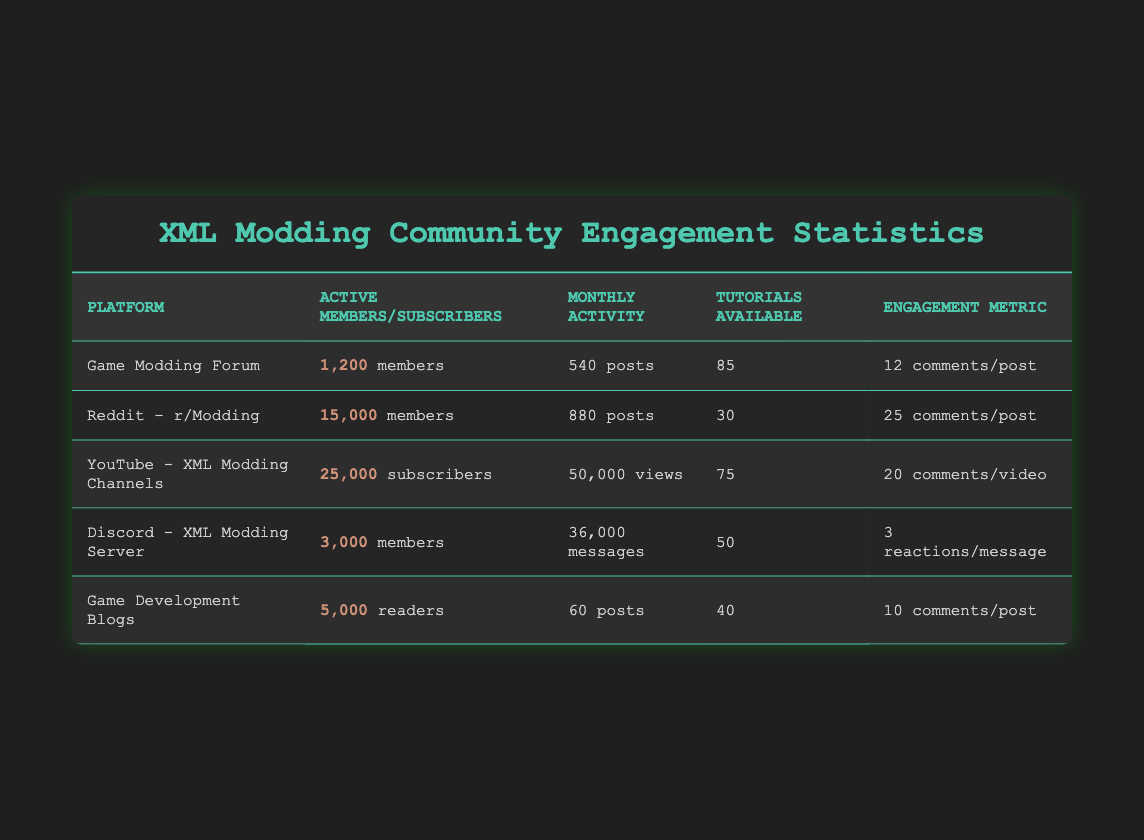What is the highest number of active members on a platform? The highest number of active members is found in "Reddit - r/Modding," which has 15,000 members. This is identified by comparing the "Active Members/Subscribers" column for each platform.
Answer: 15,000 How many monthly posts does the Game Modding Forum have? The Game Modding Forum has 540 monthly posts, as directly stated in the "Monthly Activity" column next to the entry for the Game Modding Forum.
Answer: 540 What is the total number of tutorials available across all platforms? The total number of tutorials is calculated by summing the values in the "Tutorials Available" column: 85 + 30 + 75 + 50 + 40 = 280. The final step involves adding up all these values to arrive at 280.
Answer: 280 Is it true that the YouTube - XML Modding Channels have more subscribers than the Discord - XML Modding Server has members? Yes, it is true. The YouTube platform has 25,000 subscribers while the Discord server has 3,000 members, indicating that the subscriber count on YouTube exceeds the member count on Discord.
Answer: Yes What is the average number of comments per post across the Game Modding Forum and Game Development Blogs? First, identify the average for both platforms: Game Modding Forum has 12 comments/post and Game Development Blogs has 10 comments/post. To find the average, add them: 12 + 10 = 22, then divide by 2, giving 22 / 2 = 11.
Answer: 11 Which platform has the highest average number of reactions per message? The highest average reactions per message is from the Discord - XML Modding Server, with 3 reactions per message. This is determined by comparing the "Engagement Metric" for each platform.
Answer: 3 How many monthly views are reported for YouTube - XML Modding Channels? The YouTube - XML Modding Channels report 50,000 monthly views, as specified in the "Monthly Activity" column directly next to the YouTube entry.
Answer: 50,000 Which platform has the least number of tutorials available? The platform with the least number of tutorials available is Reddit - r/Modding, which has 30 tutorials. This is determined by scanning the "Tutorials Available" column for the minimum value.
Answer: 30 What is the difference in monthly posts between Reddit - r/Modding and Game Development Blogs? To find the difference, subtract the monthly posts of Game Development Blogs (60 posts) from those of Reddit - r/Modding (880 posts): 880 - 60 = 820. Therefore, the difference is 820 monthly posts.
Answer: 820 